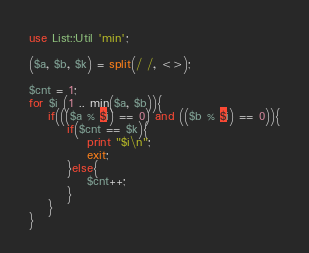Convert code to text. <code><loc_0><loc_0><loc_500><loc_500><_Perl_>use List::Util 'min';

($a, $b, $k) = split(/ /, <>);

$cnt = 1;
for $i (1 .. min($a, $b)){
	if((($a % $i) == 0) and (($b % $i) == 0)){
		if($cnt == $k){
			print "$i\n";
			exit;
		}else{
			$cnt++;
		}
	}
}</code> 